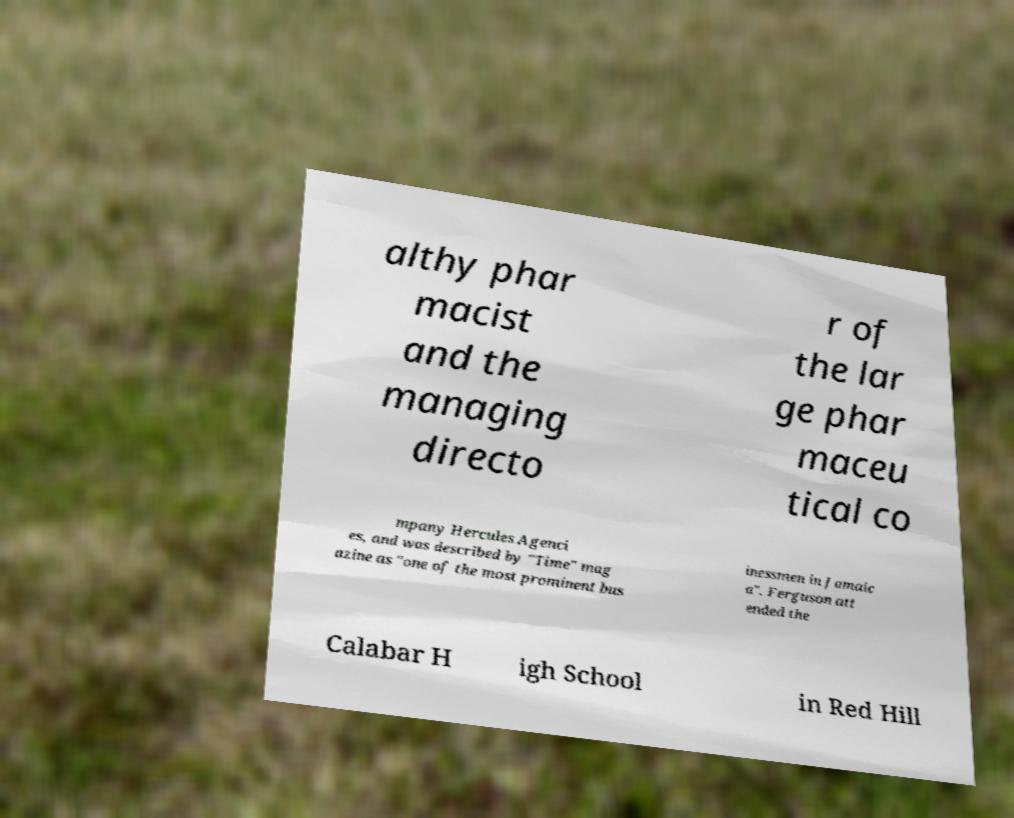For documentation purposes, I need the text within this image transcribed. Could you provide that? althy phar macist and the managing directo r of the lar ge phar maceu tical co mpany Hercules Agenci es, and was described by "Time" mag azine as "one of the most prominent bus inessmen in Jamaic a". Ferguson att ended the Calabar H igh School in Red Hill 